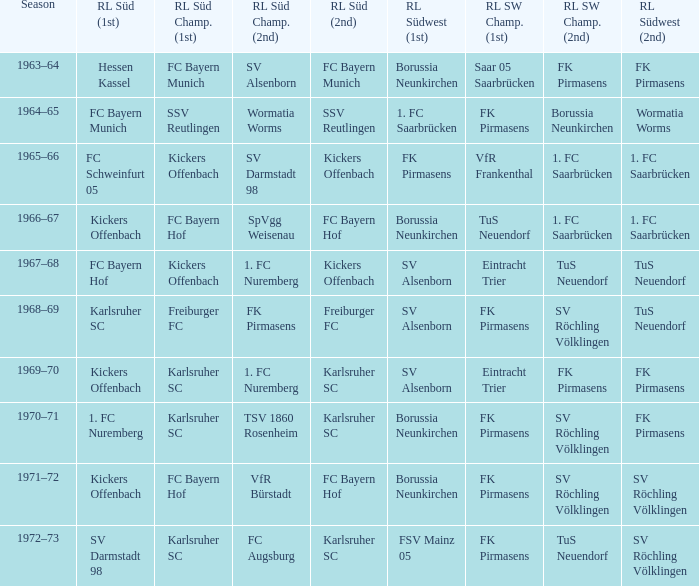What season was Freiburger FC the RL Süd (2nd) team? 1968–69. 